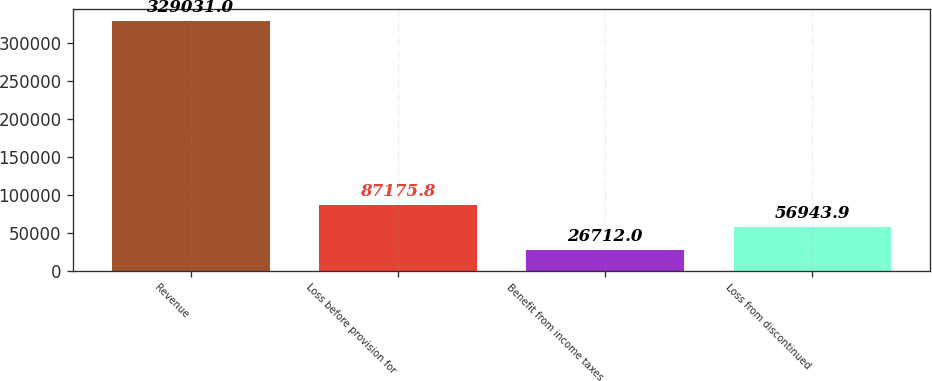<chart> <loc_0><loc_0><loc_500><loc_500><bar_chart><fcel>Revenue<fcel>Loss before provision for<fcel>Benefit from income taxes<fcel>Loss from discontinued<nl><fcel>329031<fcel>87175.8<fcel>26712<fcel>56943.9<nl></chart> 